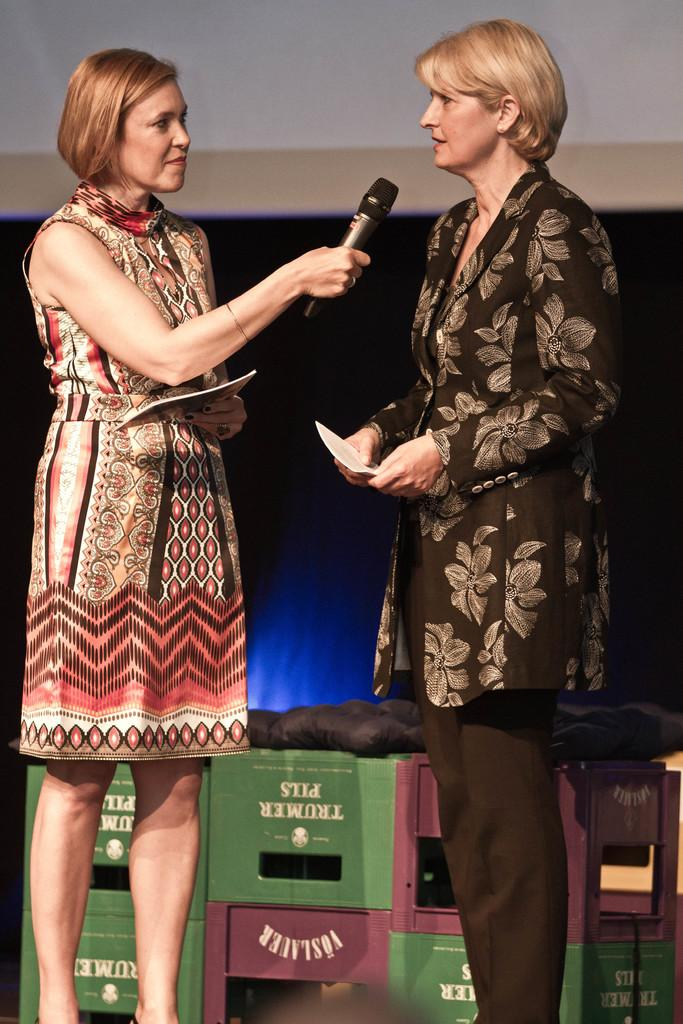How many women are present in the image? There are two women standing in the image. What is one of the women holding? There is a woman holding a mic in the image. What can be seen in the background of the image? There are boxes and other objects in the background of the image. How would you describe the lighting in the image? The background is dark in the image. What type of carriage can be seen in the image? There is no carriage present in the image. What is the size of the nose of the woman holding the mic? The image does not provide enough detail to determine the size of the woman's nose. 